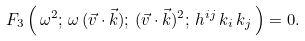Convert formula to latex. <formula><loc_0><loc_0><loc_500><loc_500>F _ { 3 } \left ( \, \omega ^ { 2 } ; \, \omega \, ( \vec { v } \cdot \vec { k } ) ; \, ( \vec { v } \cdot \vec { k } ) ^ { 2 } ; \, h ^ { i j } \, k _ { i } \, k _ { j } \, \right ) = 0 .</formula> 